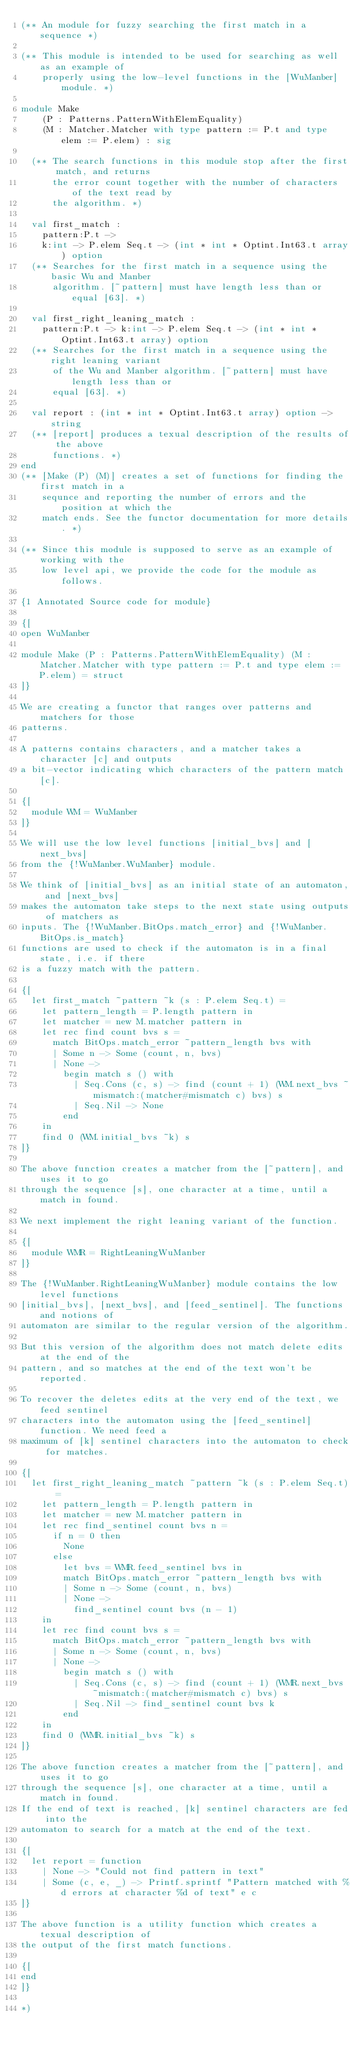<code> <loc_0><loc_0><loc_500><loc_500><_OCaml_>(** An module for fuzzy searching the first match in a sequence *)

(** This module is intended to be used for searching as well as an example of
    properly using the low-level functions in the [WuManber] module. *)

module Make
    (P : Patterns.PatternWithElemEquality)
    (M : Matcher.Matcher with type pattern := P.t and type elem := P.elem) : sig

  (** The search functions in this module stop after the first match, and returns
      the error count together with the number of characters of the text read by
      the algorithm. *)

  val first_match :
    pattern:P.t ->
    k:int -> P.elem Seq.t -> (int * int * Optint.Int63.t array) option
  (** Searches for the first match in a sequence using the basic Wu and Manber
      algorithm. [~pattern] must have length less than or equal [63]. *)

  val first_right_leaning_match :
    pattern:P.t -> k:int -> P.elem Seq.t -> (int * int * Optint.Int63.t array) option
  (** Searches for the first match in a sequence using the right leaning variant
      of the Wu and Manber algorithm. [~pattern] must have length less than or
      equal [63]. *)

  val report : (int * int * Optint.Int63.t array) option -> string
  (** [report] produces a texual description of the results of the above
      functions. *)
end
(** [Make (P) (M)] creates a set of functions for finding the first match in a
    sequnce and reporting the number of errors and the position at which the
    match ends. See the functor documentation for more details. *)

(** Since this module is supposed to serve as an example of working with the
    low level api, we provide the code for the module as follows.

{1 Annotated Source code for module}

{[
open WuManber

module Make (P : Patterns.PatternWithElemEquality) (M : Matcher.Matcher with type pattern := P.t and type elem := P.elem) = struct
]}

We are creating a functor that ranges over patterns and matchers for those
patterns.

A patterns contains characters, and a matcher takes a character [c] and outputs
a bit-vector indicating which characters of the pattern match [c].

{[
  module WM = WuManber
]}

We will use the low level functions [initial_bvs] and [next_bvs]
from the {!WuManber.WuManber} module.

We think of [initial_bvs] as an initial state of an automaton, and [next_bvs]
makes the automaton take steps to the next state using outputs of matchers as
inputs. The {!WuManber.BitOps.match_error} and {!WuManber.BitOps.is_match}
functions are used to check if the automaton is in a final state, i.e. if there
is a fuzzy match with the pattern.

{[
  let first_match ~pattern ~k (s : P.elem Seq.t) =
    let pattern_length = P.length pattern in
    let matcher = new M.matcher pattern in
    let rec find count bvs s =
      match BitOps.match_error ~pattern_length bvs with
      | Some n -> Some (count, n, bvs)
      | None ->
        begin match s () with
          | Seq.Cons (c, s) -> find (count + 1) (WM.next_bvs ~mismatch:(matcher#mismatch c) bvs) s
          | Seq.Nil -> None
        end
    in
    find 0 (WM.initial_bvs ~k) s
]}

The above function creates a matcher from the [~pattern], and uses it to go
through the sequence [s], one character at a time, until a match in found.

We next implement the right leaning variant of the function.

{[
  module WMR = RightLeaningWuManber
]}

The {!WuManber.RightLeaningWuManber} module contains the low level functions
[initial_bvs], [next_bvs], and [feed_sentinel]. The functions and notions of
automaton are similar to the regular version of the algorithm.

But this version of the algorithm does not match delete edits at the end of the
pattern, and so matches at the end of the text won't be reported.

To recover the deletes edits at the very end of the text, we feed sentinel
characters into the automaton using the [feed_sentinel] function. We need feed a
maximum of [k] sentinel characters into the automaton to check for matches.

{[
  let first_right_leaning_match ~pattern ~k (s : P.elem Seq.t) =
    let pattern_length = P.length pattern in
    let matcher = new M.matcher pattern in
    let rec find_sentinel count bvs n =
      if n = 0 then
        None
      else
        let bvs = WMR.feed_sentinel bvs in
        match BitOps.match_error ~pattern_length bvs with
        | Some n -> Some (count, n, bvs)
        | None ->
          find_sentinel count bvs (n - 1)
    in
    let rec find count bvs s =
      match BitOps.match_error ~pattern_length bvs with
      | Some n -> Some (count, n, bvs)
      | None ->
        begin match s () with
          | Seq.Cons (c, s) -> find (count + 1) (WMR.next_bvs ~mismatch:(matcher#mismatch c) bvs) s
          | Seq.Nil -> find_sentinel count bvs k
        end
    in
    find 0 (WMR.initial_bvs ~k) s
]}

The above function creates a matcher from the [~pattern], and uses it to go
through the sequence [s], one character at a time, until a match in found.
If the end of text is reached, [k] sentinel characters are fed into the
automaton to search for a match at the end of the text.

{[
  let report = function
    | None -> "Could not find pattern in text"
    | Some (c, e, _) -> Printf.sprintf "Pattern matched with %d errors at character %d of text" e c
]}

The above function is a utility function which creates a texual description of
the output of the first match functions.

{[
end
]}

*)
</code> 